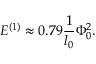Convert formula to latex. <formula><loc_0><loc_0><loc_500><loc_500>E ^ { ( 1 ) } \approx 0 . 7 9 \frac { 1 } { l _ { 0 } } \Phi _ { 0 } ^ { 2 } .</formula> 